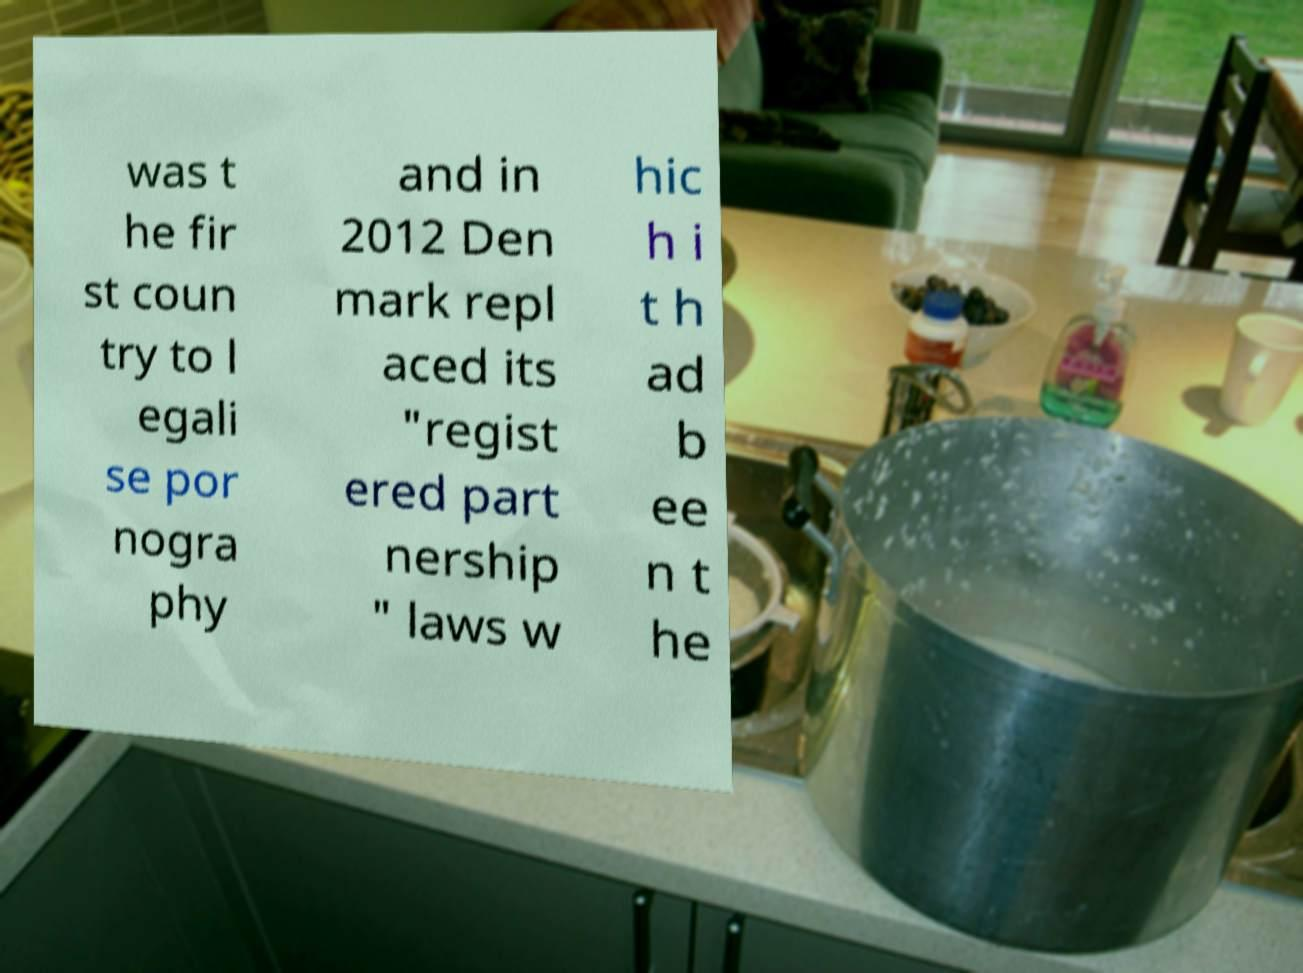Please read and relay the text visible in this image. What does it say? was t he fir st coun try to l egali se por nogra phy and in 2012 Den mark repl aced its "regist ered part nership " laws w hic h i t h ad b ee n t he 